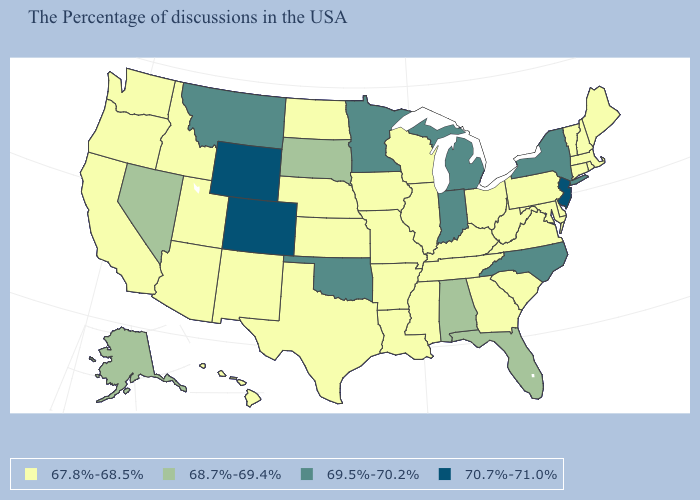Name the states that have a value in the range 67.8%-68.5%?
Give a very brief answer. Maine, Massachusetts, Rhode Island, New Hampshire, Vermont, Connecticut, Delaware, Maryland, Pennsylvania, Virginia, South Carolina, West Virginia, Ohio, Georgia, Kentucky, Tennessee, Wisconsin, Illinois, Mississippi, Louisiana, Missouri, Arkansas, Iowa, Kansas, Nebraska, Texas, North Dakota, New Mexico, Utah, Arizona, Idaho, California, Washington, Oregon, Hawaii. Which states hav the highest value in the Northeast?
Give a very brief answer. New Jersey. What is the value of West Virginia?
Be succinct. 67.8%-68.5%. What is the value of Kentucky?
Answer briefly. 67.8%-68.5%. Name the states that have a value in the range 68.7%-69.4%?
Keep it brief. Florida, Alabama, South Dakota, Nevada, Alaska. What is the value of South Carolina?
Quick response, please. 67.8%-68.5%. Which states have the lowest value in the West?
Be succinct. New Mexico, Utah, Arizona, Idaho, California, Washington, Oregon, Hawaii. What is the lowest value in the West?
Short answer required. 67.8%-68.5%. Does Michigan have the lowest value in the MidWest?
Keep it brief. No. What is the highest value in states that border Nebraska?
Quick response, please. 70.7%-71.0%. Does Arkansas have a lower value than Illinois?
Short answer required. No. Which states have the highest value in the USA?
Keep it brief. New Jersey, Wyoming, Colorado. Does Massachusetts have the highest value in the Northeast?
Quick response, please. No. Which states have the lowest value in the South?
Answer briefly. Delaware, Maryland, Virginia, South Carolina, West Virginia, Georgia, Kentucky, Tennessee, Mississippi, Louisiana, Arkansas, Texas. Which states hav the highest value in the South?
Give a very brief answer. North Carolina, Oklahoma. 